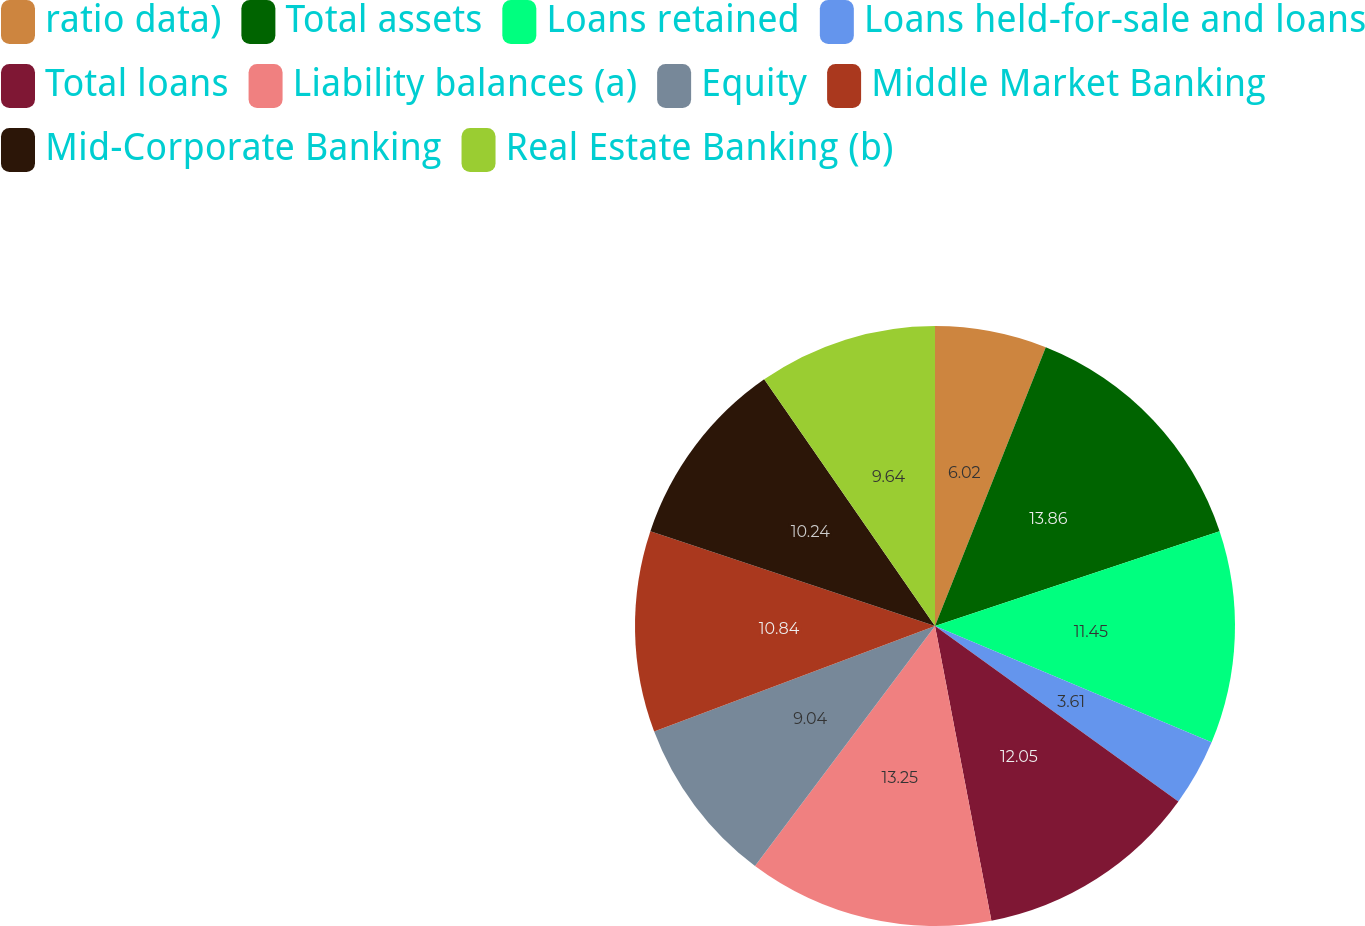<chart> <loc_0><loc_0><loc_500><loc_500><pie_chart><fcel>ratio data)<fcel>Total assets<fcel>Loans retained<fcel>Loans held-for-sale and loans<fcel>Total loans<fcel>Liability balances (a)<fcel>Equity<fcel>Middle Market Banking<fcel>Mid-Corporate Banking<fcel>Real Estate Banking (b)<nl><fcel>6.02%<fcel>13.86%<fcel>11.45%<fcel>3.61%<fcel>12.05%<fcel>13.25%<fcel>9.04%<fcel>10.84%<fcel>10.24%<fcel>9.64%<nl></chart> 